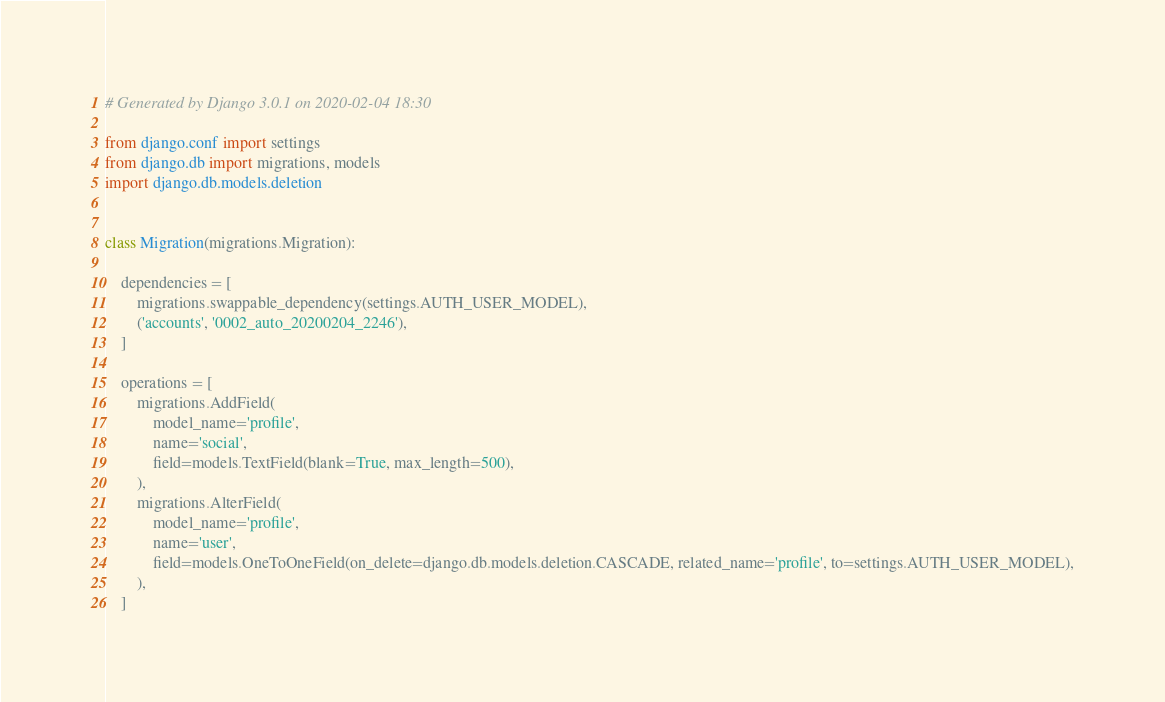<code> <loc_0><loc_0><loc_500><loc_500><_Python_># Generated by Django 3.0.1 on 2020-02-04 18:30

from django.conf import settings
from django.db import migrations, models
import django.db.models.deletion


class Migration(migrations.Migration):

    dependencies = [
        migrations.swappable_dependency(settings.AUTH_USER_MODEL),
        ('accounts', '0002_auto_20200204_2246'),
    ]

    operations = [
        migrations.AddField(
            model_name='profile',
            name='social',
            field=models.TextField(blank=True, max_length=500),
        ),
        migrations.AlterField(
            model_name='profile',
            name='user',
            field=models.OneToOneField(on_delete=django.db.models.deletion.CASCADE, related_name='profile', to=settings.AUTH_USER_MODEL),
        ),
    ]
</code> 